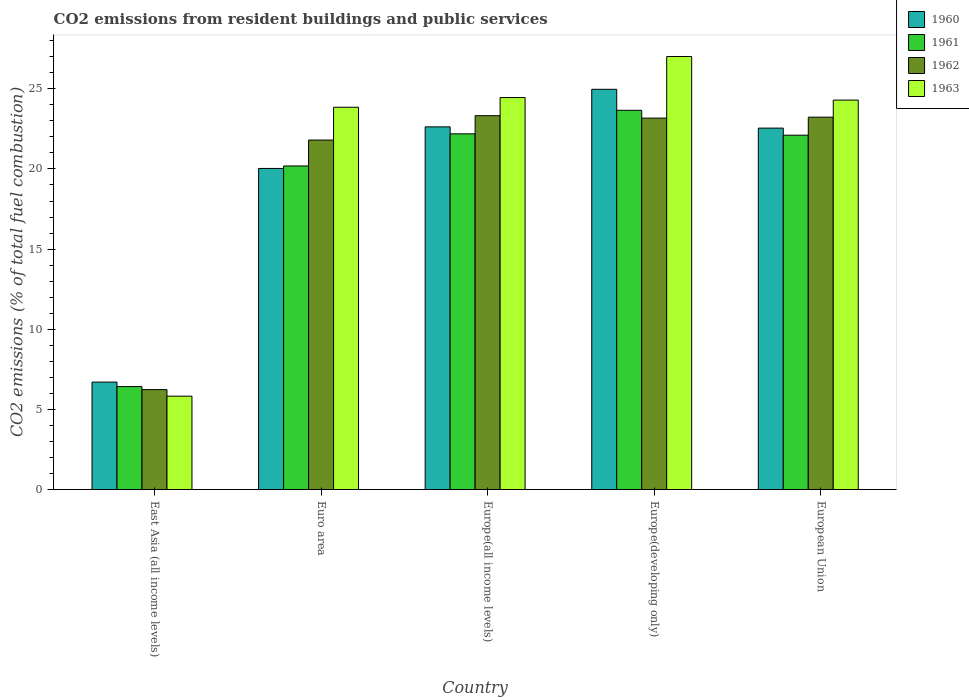How many different coloured bars are there?
Offer a terse response. 4. How many groups of bars are there?
Your response must be concise. 5. How many bars are there on the 2nd tick from the left?
Provide a short and direct response. 4. What is the label of the 1st group of bars from the left?
Ensure brevity in your answer.  East Asia (all income levels). In how many cases, is the number of bars for a given country not equal to the number of legend labels?
Provide a succinct answer. 0. What is the total CO2 emitted in 1963 in Europe(all income levels)?
Offer a terse response. 24.45. Across all countries, what is the maximum total CO2 emitted in 1960?
Offer a terse response. 24.97. Across all countries, what is the minimum total CO2 emitted in 1962?
Make the answer very short. 6.23. In which country was the total CO2 emitted in 1962 maximum?
Offer a very short reply. Europe(all income levels). In which country was the total CO2 emitted in 1960 minimum?
Offer a terse response. East Asia (all income levels). What is the total total CO2 emitted in 1960 in the graph?
Provide a short and direct response. 96.88. What is the difference between the total CO2 emitted in 1961 in Europe(all income levels) and that in Europe(developing only)?
Give a very brief answer. -1.47. What is the difference between the total CO2 emitted in 1963 in East Asia (all income levels) and the total CO2 emitted in 1961 in Euro area?
Make the answer very short. -14.36. What is the average total CO2 emitted in 1963 per country?
Provide a succinct answer. 21.09. What is the difference between the total CO2 emitted of/in 1963 and total CO2 emitted of/in 1960 in East Asia (all income levels)?
Provide a succinct answer. -0.88. In how many countries, is the total CO2 emitted in 1962 greater than 10?
Provide a short and direct response. 4. What is the ratio of the total CO2 emitted in 1962 in East Asia (all income levels) to that in European Union?
Keep it short and to the point. 0.27. Is the total CO2 emitted in 1962 in Europe(all income levels) less than that in Europe(developing only)?
Make the answer very short. No. What is the difference between the highest and the second highest total CO2 emitted in 1963?
Keep it short and to the point. 0.16. What is the difference between the highest and the lowest total CO2 emitted in 1963?
Make the answer very short. 21.19. Is the sum of the total CO2 emitted in 1963 in Europe(developing only) and European Union greater than the maximum total CO2 emitted in 1960 across all countries?
Ensure brevity in your answer.  Yes. What does the 1st bar from the left in Euro area represents?
Offer a very short reply. 1960. Is it the case that in every country, the sum of the total CO2 emitted in 1962 and total CO2 emitted in 1963 is greater than the total CO2 emitted in 1960?
Provide a succinct answer. Yes. Are all the bars in the graph horizontal?
Provide a succinct answer. No. How many countries are there in the graph?
Provide a succinct answer. 5. What is the difference between two consecutive major ticks on the Y-axis?
Offer a terse response. 5. Are the values on the major ticks of Y-axis written in scientific E-notation?
Provide a succinct answer. No. Does the graph contain grids?
Ensure brevity in your answer.  No. Where does the legend appear in the graph?
Provide a short and direct response. Top right. What is the title of the graph?
Your answer should be compact. CO2 emissions from resident buildings and public services. Does "1981" appear as one of the legend labels in the graph?
Make the answer very short. No. What is the label or title of the X-axis?
Your answer should be compact. Country. What is the label or title of the Y-axis?
Your answer should be very brief. CO2 emissions (% of total fuel combustion). What is the CO2 emissions (% of total fuel combustion) in 1960 in East Asia (all income levels)?
Provide a succinct answer. 6.7. What is the CO2 emissions (% of total fuel combustion) of 1961 in East Asia (all income levels)?
Your answer should be very brief. 6.42. What is the CO2 emissions (% of total fuel combustion) of 1962 in East Asia (all income levels)?
Provide a short and direct response. 6.23. What is the CO2 emissions (% of total fuel combustion) in 1963 in East Asia (all income levels)?
Your response must be concise. 5.82. What is the CO2 emissions (% of total fuel combustion) of 1960 in Euro area?
Provide a short and direct response. 20.03. What is the CO2 emissions (% of total fuel combustion) in 1961 in Euro area?
Provide a succinct answer. 20.19. What is the CO2 emissions (% of total fuel combustion) of 1962 in Euro area?
Your answer should be compact. 21.8. What is the CO2 emissions (% of total fuel combustion) in 1963 in Euro area?
Keep it short and to the point. 23.85. What is the CO2 emissions (% of total fuel combustion) of 1960 in Europe(all income levels)?
Give a very brief answer. 22.63. What is the CO2 emissions (% of total fuel combustion) in 1961 in Europe(all income levels)?
Give a very brief answer. 22.19. What is the CO2 emissions (% of total fuel combustion) of 1962 in Europe(all income levels)?
Your answer should be very brief. 23.32. What is the CO2 emissions (% of total fuel combustion) in 1963 in Europe(all income levels)?
Make the answer very short. 24.45. What is the CO2 emissions (% of total fuel combustion) in 1960 in Europe(developing only)?
Offer a terse response. 24.97. What is the CO2 emissions (% of total fuel combustion) in 1961 in Europe(developing only)?
Make the answer very short. 23.66. What is the CO2 emissions (% of total fuel combustion) of 1962 in Europe(developing only)?
Provide a succinct answer. 23.17. What is the CO2 emissions (% of total fuel combustion) of 1963 in Europe(developing only)?
Ensure brevity in your answer.  27.01. What is the CO2 emissions (% of total fuel combustion) of 1960 in European Union?
Your answer should be very brief. 22.55. What is the CO2 emissions (% of total fuel combustion) of 1961 in European Union?
Provide a succinct answer. 22.11. What is the CO2 emissions (% of total fuel combustion) in 1962 in European Union?
Keep it short and to the point. 23.23. What is the CO2 emissions (% of total fuel combustion) of 1963 in European Union?
Offer a very short reply. 24.3. Across all countries, what is the maximum CO2 emissions (% of total fuel combustion) of 1960?
Offer a very short reply. 24.97. Across all countries, what is the maximum CO2 emissions (% of total fuel combustion) in 1961?
Your response must be concise. 23.66. Across all countries, what is the maximum CO2 emissions (% of total fuel combustion) of 1962?
Ensure brevity in your answer.  23.32. Across all countries, what is the maximum CO2 emissions (% of total fuel combustion) of 1963?
Keep it short and to the point. 27.01. Across all countries, what is the minimum CO2 emissions (% of total fuel combustion) in 1960?
Offer a terse response. 6.7. Across all countries, what is the minimum CO2 emissions (% of total fuel combustion) in 1961?
Ensure brevity in your answer.  6.42. Across all countries, what is the minimum CO2 emissions (% of total fuel combustion) of 1962?
Provide a short and direct response. 6.23. Across all countries, what is the minimum CO2 emissions (% of total fuel combustion) in 1963?
Offer a very short reply. 5.82. What is the total CO2 emissions (% of total fuel combustion) in 1960 in the graph?
Your response must be concise. 96.88. What is the total CO2 emissions (% of total fuel combustion) of 1961 in the graph?
Offer a very short reply. 94.57. What is the total CO2 emissions (% of total fuel combustion) of 1962 in the graph?
Offer a very short reply. 97.77. What is the total CO2 emissions (% of total fuel combustion) in 1963 in the graph?
Your answer should be very brief. 105.44. What is the difference between the CO2 emissions (% of total fuel combustion) in 1960 in East Asia (all income levels) and that in Euro area?
Your answer should be very brief. -13.33. What is the difference between the CO2 emissions (% of total fuel combustion) in 1961 in East Asia (all income levels) and that in Euro area?
Your response must be concise. -13.76. What is the difference between the CO2 emissions (% of total fuel combustion) of 1962 in East Asia (all income levels) and that in Euro area?
Provide a short and direct response. -15.57. What is the difference between the CO2 emissions (% of total fuel combustion) in 1963 in East Asia (all income levels) and that in Euro area?
Your answer should be very brief. -18.03. What is the difference between the CO2 emissions (% of total fuel combustion) in 1960 in East Asia (all income levels) and that in Europe(all income levels)?
Make the answer very short. -15.92. What is the difference between the CO2 emissions (% of total fuel combustion) of 1961 in East Asia (all income levels) and that in Europe(all income levels)?
Your response must be concise. -15.77. What is the difference between the CO2 emissions (% of total fuel combustion) of 1962 in East Asia (all income levels) and that in Europe(all income levels)?
Your answer should be very brief. -17.09. What is the difference between the CO2 emissions (% of total fuel combustion) of 1963 in East Asia (all income levels) and that in Europe(all income levels)?
Make the answer very short. -18.63. What is the difference between the CO2 emissions (% of total fuel combustion) in 1960 in East Asia (all income levels) and that in Europe(developing only)?
Offer a very short reply. -18.27. What is the difference between the CO2 emissions (% of total fuel combustion) of 1961 in East Asia (all income levels) and that in Europe(developing only)?
Your answer should be very brief. -17.24. What is the difference between the CO2 emissions (% of total fuel combustion) in 1962 in East Asia (all income levels) and that in Europe(developing only)?
Keep it short and to the point. -16.94. What is the difference between the CO2 emissions (% of total fuel combustion) in 1963 in East Asia (all income levels) and that in Europe(developing only)?
Your response must be concise. -21.19. What is the difference between the CO2 emissions (% of total fuel combustion) in 1960 in East Asia (all income levels) and that in European Union?
Offer a very short reply. -15.85. What is the difference between the CO2 emissions (% of total fuel combustion) in 1961 in East Asia (all income levels) and that in European Union?
Keep it short and to the point. -15.68. What is the difference between the CO2 emissions (% of total fuel combustion) in 1962 in East Asia (all income levels) and that in European Union?
Provide a short and direct response. -17. What is the difference between the CO2 emissions (% of total fuel combustion) of 1963 in East Asia (all income levels) and that in European Union?
Make the answer very short. -18.47. What is the difference between the CO2 emissions (% of total fuel combustion) in 1960 in Euro area and that in Europe(all income levels)?
Make the answer very short. -2.59. What is the difference between the CO2 emissions (% of total fuel combustion) in 1961 in Euro area and that in Europe(all income levels)?
Give a very brief answer. -2. What is the difference between the CO2 emissions (% of total fuel combustion) of 1962 in Euro area and that in Europe(all income levels)?
Your answer should be compact. -1.52. What is the difference between the CO2 emissions (% of total fuel combustion) in 1963 in Euro area and that in Europe(all income levels)?
Your response must be concise. -0.6. What is the difference between the CO2 emissions (% of total fuel combustion) in 1960 in Euro area and that in Europe(developing only)?
Your answer should be very brief. -4.94. What is the difference between the CO2 emissions (% of total fuel combustion) in 1961 in Euro area and that in Europe(developing only)?
Provide a succinct answer. -3.47. What is the difference between the CO2 emissions (% of total fuel combustion) in 1962 in Euro area and that in Europe(developing only)?
Provide a succinct answer. -1.37. What is the difference between the CO2 emissions (% of total fuel combustion) of 1963 in Euro area and that in Europe(developing only)?
Offer a terse response. -3.16. What is the difference between the CO2 emissions (% of total fuel combustion) in 1960 in Euro area and that in European Union?
Offer a very short reply. -2.52. What is the difference between the CO2 emissions (% of total fuel combustion) of 1961 in Euro area and that in European Union?
Ensure brevity in your answer.  -1.92. What is the difference between the CO2 emissions (% of total fuel combustion) of 1962 in Euro area and that in European Union?
Give a very brief answer. -1.43. What is the difference between the CO2 emissions (% of total fuel combustion) in 1963 in Euro area and that in European Union?
Ensure brevity in your answer.  -0.45. What is the difference between the CO2 emissions (% of total fuel combustion) of 1960 in Europe(all income levels) and that in Europe(developing only)?
Ensure brevity in your answer.  -2.34. What is the difference between the CO2 emissions (% of total fuel combustion) of 1961 in Europe(all income levels) and that in Europe(developing only)?
Your answer should be very brief. -1.47. What is the difference between the CO2 emissions (% of total fuel combustion) of 1962 in Europe(all income levels) and that in Europe(developing only)?
Give a very brief answer. 0.15. What is the difference between the CO2 emissions (% of total fuel combustion) in 1963 in Europe(all income levels) and that in Europe(developing only)?
Offer a very short reply. -2.56. What is the difference between the CO2 emissions (% of total fuel combustion) of 1960 in Europe(all income levels) and that in European Union?
Provide a short and direct response. 0.08. What is the difference between the CO2 emissions (% of total fuel combustion) in 1961 in Europe(all income levels) and that in European Union?
Give a very brief answer. 0.08. What is the difference between the CO2 emissions (% of total fuel combustion) of 1962 in Europe(all income levels) and that in European Union?
Your answer should be compact. 0.09. What is the difference between the CO2 emissions (% of total fuel combustion) of 1963 in Europe(all income levels) and that in European Union?
Ensure brevity in your answer.  0.16. What is the difference between the CO2 emissions (% of total fuel combustion) of 1960 in Europe(developing only) and that in European Union?
Keep it short and to the point. 2.42. What is the difference between the CO2 emissions (% of total fuel combustion) in 1961 in Europe(developing only) and that in European Union?
Give a very brief answer. 1.55. What is the difference between the CO2 emissions (% of total fuel combustion) in 1962 in Europe(developing only) and that in European Union?
Ensure brevity in your answer.  -0.06. What is the difference between the CO2 emissions (% of total fuel combustion) of 1963 in Europe(developing only) and that in European Union?
Keep it short and to the point. 2.72. What is the difference between the CO2 emissions (% of total fuel combustion) in 1960 in East Asia (all income levels) and the CO2 emissions (% of total fuel combustion) in 1961 in Euro area?
Your answer should be compact. -13.48. What is the difference between the CO2 emissions (% of total fuel combustion) in 1960 in East Asia (all income levels) and the CO2 emissions (% of total fuel combustion) in 1962 in Euro area?
Give a very brief answer. -15.1. What is the difference between the CO2 emissions (% of total fuel combustion) in 1960 in East Asia (all income levels) and the CO2 emissions (% of total fuel combustion) in 1963 in Euro area?
Your response must be concise. -17.15. What is the difference between the CO2 emissions (% of total fuel combustion) in 1961 in East Asia (all income levels) and the CO2 emissions (% of total fuel combustion) in 1962 in Euro area?
Your answer should be very brief. -15.38. What is the difference between the CO2 emissions (% of total fuel combustion) in 1961 in East Asia (all income levels) and the CO2 emissions (% of total fuel combustion) in 1963 in Euro area?
Give a very brief answer. -17.43. What is the difference between the CO2 emissions (% of total fuel combustion) in 1962 in East Asia (all income levels) and the CO2 emissions (% of total fuel combustion) in 1963 in Euro area?
Provide a succinct answer. -17.62. What is the difference between the CO2 emissions (% of total fuel combustion) of 1960 in East Asia (all income levels) and the CO2 emissions (% of total fuel combustion) of 1961 in Europe(all income levels)?
Keep it short and to the point. -15.49. What is the difference between the CO2 emissions (% of total fuel combustion) of 1960 in East Asia (all income levels) and the CO2 emissions (% of total fuel combustion) of 1962 in Europe(all income levels)?
Your response must be concise. -16.62. What is the difference between the CO2 emissions (% of total fuel combustion) of 1960 in East Asia (all income levels) and the CO2 emissions (% of total fuel combustion) of 1963 in Europe(all income levels)?
Your answer should be very brief. -17.75. What is the difference between the CO2 emissions (% of total fuel combustion) in 1961 in East Asia (all income levels) and the CO2 emissions (% of total fuel combustion) in 1962 in Europe(all income levels)?
Keep it short and to the point. -16.9. What is the difference between the CO2 emissions (% of total fuel combustion) of 1961 in East Asia (all income levels) and the CO2 emissions (% of total fuel combustion) of 1963 in Europe(all income levels)?
Give a very brief answer. -18.03. What is the difference between the CO2 emissions (% of total fuel combustion) in 1962 in East Asia (all income levels) and the CO2 emissions (% of total fuel combustion) in 1963 in Europe(all income levels)?
Your response must be concise. -18.22. What is the difference between the CO2 emissions (% of total fuel combustion) of 1960 in East Asia (all income levels) and the CO2 emissions (% of total fuel combustion) of 1961 in Europe(developing only)?
Your answer should be very brief. -16.96. What is the difference between the CO2 emissions (% of total fuel combustion) in 1960 in East Asia (all income levels) and the CO2 emissions (% of total fuel combustion) in 1962 in Europe(developing only)?
Offer a very short reply. -16.47. What is the difference between the CO2 emissions (% of total fuel combustion) in 1960 in East Asia (all income levels) and the CO2 emissions (% of total fuel combustion) in 1963 in Europe(developing only)?
Offer a terse response. -20.31. What is the difference between the CO2 emissions (% of total fuel combustion) in 1961 in East Asia (all income levels) and the CO2 emissions (% of total fuel combustion) in 1962 in Europe(developing only)?
Provide a short and direct response. -16.75. What is the difference between the CO2 emissions (% of total fuel combustion) in 1961 in East Asia (all income levels) and the CO2 emissions (% of total fuel combustion) in 1963 in Europe(developing only)?
Your response must be concise. -20.59. What is the difference between the CO2 emissions (% of total fuel combustion) in 1962 in East Asia (all income levels) and the CO2 emissions (% of total fuel combustion) in 1963 in Europe(developing only)?
Give a very brief answer. -20.78. What is the difference between the CO2 emissions (% of total fuel combustion) of 1960 in East Asia (all income levels) and the CO2 emissions (% of total fuel combustion) of 1961 in European Union?
Offer a terse response. -15.4. What is the difference between the CO2 emissions (% of total fuel combustion) of 1960 in East Asia (all income levels) and the CO2 emissions (% of total fuel combustion) of 1962 in European Union?
Make the answer very short. -16.53. What is the difference between the CO2 emissions (% of total fuel combustion) of 1960 in East Asia (all income levels) and the CO2 emissions (% of total fuel combustion) of 1963 in European Union?
Your answer should be compact. -17.59. What is the difference between the CO2 emissions (% of total fuel combustion) in 1961 in East Asia (all income levels) and the CO2 emissions (% of total fuel combustion) in 1962 in European Union?
Provide a short and direct response. -16.81. What is the difference between the CO2 emissions (% of total fuel combustion) in 1961 in East Asia (all income levels) and the CO2 emissions (% of total fuel combustion) in 1963 in European Union?
Give a very brief answer. -17.87. What is the difference between the CO2 emissions (% of total fuel combustion) of 1962 in East Asia (all income levels) and the CO2 emissions (% of total fuel combustion) of 1963 in European Union?
Your response must be concise. -18.06. What is the difference between the CO2 emissions (% of total fuel combustion) in 1960 in Euro area and the CO2 emissions (% of total fuel combustion) in 1961 in Europe(all income levels)?
Your answer should be very brief. -2.16. What is the difference between the CO2 emissions (% of total fuel combustion) in 1960 in Euro area and the CO2 emissions (% of total fuel combustion) in 1962 in Europe(all income levels)?
Keep it short and to the point. -3.29. What is the difference between the CO2 emissions (% of total fuel combustion) of 1960 in Euro area and the CO2 emissions (% of total fuel combustion) of 1963 in Europe(all income levels)?
Offer a very short reply. -4.42. What is the difference between the CO2 emissions (% of total fuel combustion) in 1961 in Euro area and the CO2 emissions (% of total fuel combustion) in 1962 in Europe(all income levels)?
Keep it short and to the point. -3.14. What is the difference between the CO2 emissions (% of total fuel combustion) in 1961 in Euro area and the CO2 emissions (% of total fuel combustion) in 1963 in Europe(all income levels)?
Provide a short and direct response. -4.27. What is the difference between the CO2 emissions (% of total fuel combustion) of 1962 in Euro area and the CO2 emissions (% of total fuel combustion) of 1963 in Europe(all income levels)?
Provide a succinct answer. -2.65. What is the difference between the CO2 emissions (% of total fuel combustion) in 1960 in Euro area and the CO2 emissions (% of total fuel combustion) in 1961 in Europe(developing only)?
Offer a terse response. -3.63. What is the difference between the CO2 emissions (% of total fuel combustion) of 1960 in Euro area and the CO2 emissions (% of total fuel combustion) of 1962 in Europe(developing only)?
Give a very brief answer. -3.14. What is the difference between the CO2 emissions (% of total fuel combustion) in 1960 in Euro area and the CO2 emissions (% of total fuel combustion) in 1963 in Europe(developing only)?
Your response must be concise. -6.98. What is the difference between the CO2 emissions (% of total fuel combustion) in 1961 in Euro area and the CO2 emissions (% of total fuel combustion) in 1962 in Europe(developing only)?
Your answer should be compact. -2.99. What is the difference between the CO2 emissions (% of total fuel combustion) in 1961 in Euro area and the CO2 emissions (% of total fuel combustion) in 1963 in Europe(developing only)?
Provide a short and direct response. -6.83. What is the difference between the CO2 emissions (% of total fuel combustion) in 1962 in Euro area and the CO2 emissions (% of total fuel combustion) in 1963 in Europe(developing only)?
Your answer should be compact. -5.21. What is the difference between the CO2 emissions (% of total fuel combustion) in 1960 in Euro area and the CO2 emissions (% of total fuel combustion) in 1961 in European Union?
Offer a very short reply. -2.07. What is the difference between the CO2 emissions (% of total fuel combustion) in 1960 in Euro area and the CO2 emissions (% of total fuel combustion) in 1962 in European Union?
Your answer should be compact. -3.2. What is the difference between the CO2 emissions (% of total fuel combustion) in 1960 in Euro area and the CO2 emissions (% of total fuel combustion) in 1963 in European Union?
Make the answer very short. -4.26. What is the difference between the CO2 emissions (% of total fuel combustion) in 1961 in Euro area and the CO2 emissions (% of total fuel combustion) in 1962 in European Union?
Provide a short and direct response. -3.04. What is the difference between the CO2 emissions (% of total fuel combustion) in 1961 in Euro area and the CO2 emissions (% of total fuel combustion) in 1963 in European Union?
Offer a very short reply. -4.11. What is the difference between the CO2 emissions (% of total fuel combustion) of 1962 in Euro area and the CO2 emissions (% of total fuel combustion) of 1963 in European Union?
Keep it short and to the point. -2.49. What is the difference between the CO2 emissions (% of total fuel combustion) in 1960 in Europe(all income levels) and the CO2 emissions (% of total fuel combustion) in 1961 in Europe(developing only)?
Ensure brevity in your answer.  -1.03. What is the difference between the CO2 emissions (% of total fuel combustion) in 1960 in Europe(all income levels) and the CO2 emissions (% of total fuel combustion) in 1962 in Europe(developing only)?
Make the answer very short. -0.55. What is the difference between the CO2 emissions (% of total fuel combustion) in 1960 in Europe(all income levels) and the CO2 emissions (% of total fuel combustion) in 1963 in Europe(developing only)?
Keep it short and to the point. -4.39. What is the difference between the CO2 emissions (% of total fuel combustion) in 1961 in Europe(all income levels) and the CO2 emissions (% of total fuel combustion) in 1962 in Europe(developing only)?
Offer a terse response. -0.98. What is the difference between the CO2 emissions (% of total fuel combustion) in 1961 in Europe(all income levels) and the CO2 emissions (% of total fuel combustion) in 1963 in Europe(developing only)?
Your response must be concise. -4.82. What is the difference between the CO2 emissions (% of total fuel combustion) in 1962 in Europe(all income levels) and the CO2 emissions (% of total fuel combustion) in 1963 in Europe(developing only)?
Keep it short and to the point. -3.69. What is the difference between the CO2 emissions (% of total fuel combustion) of 1960 in Europe(all income levels) and the CO2 emissions (% of total fuel combustion) of 1961 in European Union?
Offer a very short reply. 0.52. What is the difference between the CO2 emissions (% of total fuel combustion) of 1960 in Europe(all income levels) and the CO2 emissions (% of total fuel combustion) of 1962 in European Union?
Offer a very short reply. -0.61. What is the difference between the CO2 emissions (% of total fuel combustion) of 1960 in Europe(all income levels) and the CO2 emissions (% of total fuel combustion) of 1963 in European Union?
Offer a terse response. -1.67. What is the difference between the CO2 emissions (% of total fuel combustion) in 1961 in Europe(all income levels) and the CO2 emissions (% of total fuel combustion) in 1962 in European Union?
Make the answer very short. -1.04. What is the difference between the CO2 emissions (% of total fuel combustion) in 1961 in Europe(all income levels) and the CO2 emissions (% of total fuel combustion) in 1963 in European Union?
Keep it short and to the point. -2.11. What is the difference between the CO2 emissions (% of total fuel combustion) in 1962 in Europe(all income levels) and the CO2 emissions (% of total fuel combustion) in 1963 in European Union?
Offer a very short reply. -0.97. What is the difference between the CO2 emissions (% of total fuel combustion) of 1960 in Europe(developing only) and the CO2 emissions (% of total fuel combustion) of 1961 in European Union?
Provide a short and direct response. 2.86. What is the difference between the CO2 emissions (% of total fuel combustion) in 1960 in Europe(developing only) and the CO2 emissions (% of total fuel combustion) in 1962 in European Union?
Provide a short and direct response. 1.74. What is the difference between the CO2 emissions (% of total fuel combustion) of 1960 in Europe(developing only) and the CO2 emissions (% of total fuel combustion) of 1963 in European Union?
Give a very brief answer. 0.67. What is the difference between the CO2 emissions (% of total fuel combustion) in 1961 in Europe(developing only) and the CO2 emissions (% of total fuel combustion) in 1962 in European Union?
Your response must be concise. 0.43. What is the difference between the CO2 emissions (% of total fuel combustion) in 1961 in Europe(developing only) and the CO2 emissions (% of total fuel combustion) in 1963 in European Union?
Your answer should be very brief. -0.64. What is the difference between the CO2 emissions (% of total fuel combustion) of 1962 in Europe(developing only) and the CO2 emissions (% of total fuel combustion) of 1963 in European Union?
Give a very brief answer. -1.12. What is the average CO2 emissions (% of total fuel combustion) in 1960 per country?
Ensure brevity in your answer.  19.38. What is the average CO2 emissions (% of total fuel combustion) in 1961 per country?
Make the answer very short. 18.91. What is the average CO2 emissions (% of total fuel combustion) in 1962 per country?
Make the answer very short. 19.55. What is the average CO2 emissions (% of total fuel combustion) in 1963 per country?
Ensure brevity in your answer.  21.09. What is the difference between the CO2 emissions (% of total fuel combustion) in 1960 and CO2 emissions (% of total fuel combustion) in 1961 in East Asia (all income levels)?
Offer a very short reply. 0.28. What is the difference between the CO2 emissions (% of total fuel combustion) of 1960 and CO2 emissions (% of total fuel combustion) of 1962 in East Asia (all income levels)?
Provide a succinct answer. 0.47. What is the difference between the CO2 emissions (% of total fuel combustion) in 1960 and CO2 emissions (% of total fuel combustion) in 1963 in East Asia (all income levels)?
Your answer should be compact. 0.88. What is the difference between the CO2 emissions (% of total fuel combustion) of 1961 and CO2 emissions (% of total fuel combustion) of 1962 in East Asia (all income levels)?
Make the answer very short. 0.19. What is the difference between the CO2 emissions (% of total fuel combustion) of 1961 and CO2 emissions (% of total fuel combustion) of 1963 in East Asia (all income levels)?
Make the answer very short. 0.6. What is the difference between the CO2 emissions (% of total fuel combustion) in 1962 and CO2 emissions (% of total fuel combustion) in 1963 in East Asia (all income levels)?
Provide a succinct answer. 0.41. What is the difference between the CO2 emissions (% of total fuel combustion) of 1960 and CO2 emissions (% of total fuel combustion) of 1961 in Euro area?
Provide a short and direct response. -0.15. What is the difference between the CO2 emissions (% of total fuel combustion) of 1960 and CO2 emissions (% of total fuel combustion) of 1962 in Euro area?
Provide a succinct answer. -1.77. What is the difference between the CO2 emissions (% of total fuel combustion) of 1960 and CO2 emissions (% of total fuel combustion) of 1963 in Euro area?
Offer a very short reply. -3.82. What is the difference between the CO2 emissions (% of total fuel combustion) in 1961 and CO2 emissions (% of total fuel combustion) in 1962 in Euro area?
Provide a succinct answer. -1.62. What is the difference between the CO2 emissions (% of total fuel combustion) in 1961 and CO2 emissions (% of total fuel combustion) in 1963 in Euro area?
Ensure brevity in your answer.  -3.66. What is the difference between the CO2 emissions (% of total fuel combustion) of 1962 and CO2 emissions (% of total fuel combustion) of 1963 in Euro area?
Provide a succinct answer. -2.05. What is the difference between the CO2 emissions (% of total fuel combustion) in 1960 and CO2 emissions (% of total fuel combustion) in 1961 in Europe(all income levels)?
Your answer should be very brief. 0.44. What is the difference between the CO2 emissions (% of total fuel combustion) of 1960 and CO2 emissions (% of total fuel combustion) of 1962 in Europe(all income levels)?
Your response must be concise. -0.7. What is the difference between the CO2 emissions (% of total fuel combustion) of 1960 and CO2 emissions (% of total fuel combustion) of 1963 in Europe(all income levels)?
Ensure brevity in your answer.  -1.83. What is the difference between the CO2 emissions (% of total fuel combustion) in 1961 and CO2 emissions (% of total fuel combustion) in 1962 in Europe(all income levels)?
Provide a short and direct response. -1.13. What is the difference between the CO2 emissions (% of total fuel combustion) in 1961 and CO2 emissions (% of total fuel combustion) in 1963 in Europe(all income levels)?
Offer a terse response. -2.26. What is the difference between the CO2 emissions (% of total fuel combustion) of 1962 and CO2 emissions (% of total fuel combustion) of 1963 in Europe(all income levels)?
Keep it short and to the point. -1.13. What is the difference between the CO2 emissions (% of total fuel combustion) in 1960 and CO2 emissions (% of total fuel combustion) in 1961 in Europe(developing only)?
Keep it short and to the point. 1.31. What is the difference between the CO2 emissions (% of total fuel combustion) of 1960 and CO2 emissions (% of total fuel combustion) of 1962 in Europe(developing only)?
Offer a terse response. 1.8. What is the difference between the CO2 emissions (% of total fuel combustion) in 1960 and CO2 emissions (% of total fuel combustion) in 1963 in Europe(developing only)?
Ensure brevity in your answer.  -2.05. What is the difference between the CO2 emissions (% of total fuel combustion) in 1961 and CO2 emissions (% of total fuel combustion) in 1962 in Europe(developing only)?
Make the answer very short. 0.49. What is the difference between the CO2 emissions (% of total fuel combustion) in 1961 and CO2 emissions (% of total fuel combustion) in 1963 in Europe(developing only)?
Provide a succinct answer. -3.35. What is the difference between the CO2 emissions (% of total fuel combustion) in 1962 and CO2 emissions (% of total fuel combustion) in 1963 in Europe(developing only)?
Offer a very short reply. -3.84. What is the difference between the CO2 emissions (% of total fuel combustion) of 1960 and CO2 emissions (% of total fuel combustion) of 1961 in European Union?
Offer a very short reply. 0.44. What is the difference between the CO2 emissions (% of total fuel combustion) of 1960 and CO2 emissions (% of total fuel combustion) of 1962 in European Union?
Offer a terse response. -0.68. What is the difference between the CO2 emissions (% of total fuel combustion) in 1960 and CO2 emissions (% of total fuel combustion) in 1963 in European Union?
Make the answer very short. -1.75. What is the difference between the CO2 emissions (% of total fuel combustion) of 1961 and CO2 emissions (% of total fuel combustion) of 1962 in European Union?
Provide a short and direct response. -1.13. What is the difference between the CO2 emissions (% of total fuel combustion) in 1961 and CO2 emissions (% of total fuel combustion) in 1963 in European Union?
Your response must be concise. -2.19. What is the difference between the CO2 emissions (% of total fuel combustion) in 1962 and CO2 emissions (% of total fuel combustion) in 1963 in European Union?
Your response must be concise. -1.07. What is the ratio of the CO2 emissions (% of total fuel combustion) in 1960 in East Asia (all income levels) to that in Euro area?
Provide a short and direct response. 0.33. What is the ratio of the CO2 emissions (% of total fuel combustion) of 1961 in East Asia (all income levels) to that in Euro area?
Your answer should be very brief. 0.32. What is the ratio of the CO2 emissions (% of total fuel combustion) in 1962 in East Asia (all income levels) to that in Euro area?
Your answer should be compact. 0.29. What is the ratio of the CO2 emissions (% of total fuel combustion) in 1963 in East Asia (all income levels) to that in Euro area?
Your answer should be very brief. 0.24. What is the ratio of the CO2 emissions (% of total fuel combustion) of 1960 in East Asia (all income levels) to that in Europe(all income levels)?
Give a very brief answer. 0.3. What is the ratio of the CO2 emissions (% of total fuel combustion) of 1961 in East Asia (all income levels) to that in Europe(all income levels)?
Make the answer very short. 0.29. What is the ratio of the CO2 emissions (% of total fuel combustion) of 1962 in East Asia (all income levels) to that in Europe(all income levels)?
Your answer should be compact. 0.27. What is the ratio of the CO2 emissions (% of total fuel combustion) of 1963 in East Asia (all income levels) to that in Europe(all income levels)?
Offer a very short reply. 0.24. What is the ratio of the CO2 emissions (% of total fuel combustion) of 1960 in East Asia (all income levels) to that in Europe(developing only)?
Give a very brief answer. 0.27. What is the ratio of the CO2 emissions (% of total fuel combustion) in 1961 in East Asia (all income levels) to that in Europe(developing only)?
Your answer should be compact. 0.27. What is the ratio of the CO2 emissions (% of total fuel combustion) of 1962 in East Asia (all income levels) to that in Europe(developing only)?
Keep it short and to the point. 0.27. What is the ratio of the CO2 emissions (% of total fuel combustion) of 1963 in East Asia (all income levels) to that in Europe(developing only)?
Make the answer very short. 0.22. What is the ratio of the CO2 emissions (% of total fuel combustion) of 1960 in East Asia (all income levels) to that in European Union?
Offer a terse response. 0.3. What is the ratio of the CO2 emissions (% of total fuel combustion) of 1961 in East Asia (all income levels) to that in European Union?
Keep it short and to the point. 0.29. What is the ratio of the CO2 emissions (% of total fuel combustion) of 1962 in East Asia (all income levels) to that in European Union?
Ensure brevity in your answer.  0.27. What is the ratio of the CO2 emissions (% of total fuel combustion) of 1963 in East Asia (all income levels) to that in European Union?
Give a very brief answer. 0.24. What is the ratio of the CO2 emissions (% of total fuel combustion) of 1960 in Euro area to that in Europe(all income levels)?
Your answer should be compact. 0.89. What is the ratio of the CO2 emissions (% of total fuel combustion) of 1961 in Euro area to that in Europe(all income levels)?
Your response must be concise. 0.91. What is the ratio of the CO2 emissions (% of total fuel combustion) of 1962 in Euro area to that in Europe(all income levels)?
Make the answer very short. 0.93. What is the ratio of the CO2 emissions (% of total fuel combustion) of 1963 in Euro area to that in Europe(all income levels)?
Your answer should be very brief. 0.98. What is the ratio of the CO2 emissions (% of total fuel combustion) of 1960 in Euro area to that in Europe(developing only)?
Give a very brief answer. 0.8. What is the ratio of the CO2 emissions (% of total fuel combustion) of 1961 in Euro area to that in Europe(developing only)?
Provide a succinct answer. 0.85. What is the ratio of the CO2 emissions (% of total fuel combustion) in 1962 in Euro area to that in Europe(developing only)?
Your response must be concise. 0.94. What is the ratio of the CO2 emissions (% of total fuel combustion) of 1963 in Euro area to that in Europe(developing only)?
Ensure brevity in your answer.  0.88. What is the ratio of the CO2 emissions (% of total fuel combustion) in 1960 in Euro area to that in European Union?
Ensure brevity in your answer.  0.89. What is the ratio of the CO2 emissions (% of total fuel combustion) of 1961 in Euro area to that in European Union?
Offer a very short reply. 0.91. What is the ratio of the CO2 emissions (% of total fuel combustion) in 1962 in Euro area to that in European Union?
Make the answer very short. 0.94. What is the ratio of the CO2 emissions (% of total fuel combustion) of 1963 in Euro area to that in European Union?
Give a very brief answer. 0.98. What is the ratio of the CO2 emissions (% of total fuel combustion) of 1960 in Europe(all income levels) to that in Europe(developing only)?
Offer a very short reply. 0.91. What is the ratio of the CO2 emissions (% of total fuel combustion) in 1961 in Europe(all income levels) to that in Europe(developing only)?
Make the answer very short. 0.94. What is the ratio of the CO2 emissions (% of total fuel combustion) in 1963 in Europe(all income levels) to that in Europe(developing only)?
Your answer should be very brief. 0.91. What is the ratio of the CO2 emissions (% of total fuel combustion) of 1960 in Europe(all income levels) to that in European Union?
Your answer should be compact. 1. What is the ratio of the CO2 emissions (% of total fuel combustion) in 1961 in Europe(all income levels) to that in European Union?
Keep it short and to the point. 1. What is the ratio of the CO2 emissions (% of total fuel combustion) in 1962 in Europe(all income levels) to that in European Union?
Your response must be concise. 1. What is the ratio of the CO2 emissions (% of total fuel combustion) of 1963 in Europe(all income levels) to that in European Union?
Give a very brief answer. 1.01. What is the ratio of the CO2 emissions (% of total fuel combustion) in 1960 in Europe(developing only) to that in European Union?
Your response must be concise. 1.11. What is the ratio of the CO2 emissions (% of total fuel combustion) in 1961 in Europe(developing only) to that in European Union?
Your answer should be compact. 1.07. What is the ratio of the CO2 emissions (% of total fuel combustion) of 1963 in Europe(developing only) to that in European Union?
Ensure brevity in your answer.  1.11. What is the difference between the highest and the second highest CO2 emissions (% of total fuel combustion) in 1960?
Your answer should be compact. 2.34. What is the difference between the highest and the second highest CO2 emissions (% of total fuel combustion) of 1961?
Ensure brevity in your answer.  1.47. What is the difference between the highest and the second highest CO2 emissions (% of total fuel combustion) in 1962?
Your response must be concise. 0.09. What is the difference between the highest and the second highest CO2 emissions (% of total fuel combustion) in 1963?
Offer a very short reply. 2.56. What is the difference between the highest and the lowest CO2 emissions (% of total fuel combustion) in 1960?
Offer a very short reply. 18.27. What is the difference between the highest and the lowest CO2 emissions (% of total fuel combustion) in 1961?
Your response must be concise. 17.24. What is the difference between the highest and the lowest CO2 emissions (% of total fuel combustion) of 1962?
Offer a very short reply. 17.09. What is the difference between the highest and the lowest CO2 emissions (% of total fuel combustion) of 1963?
Keep it short and to the point. 21.19. 